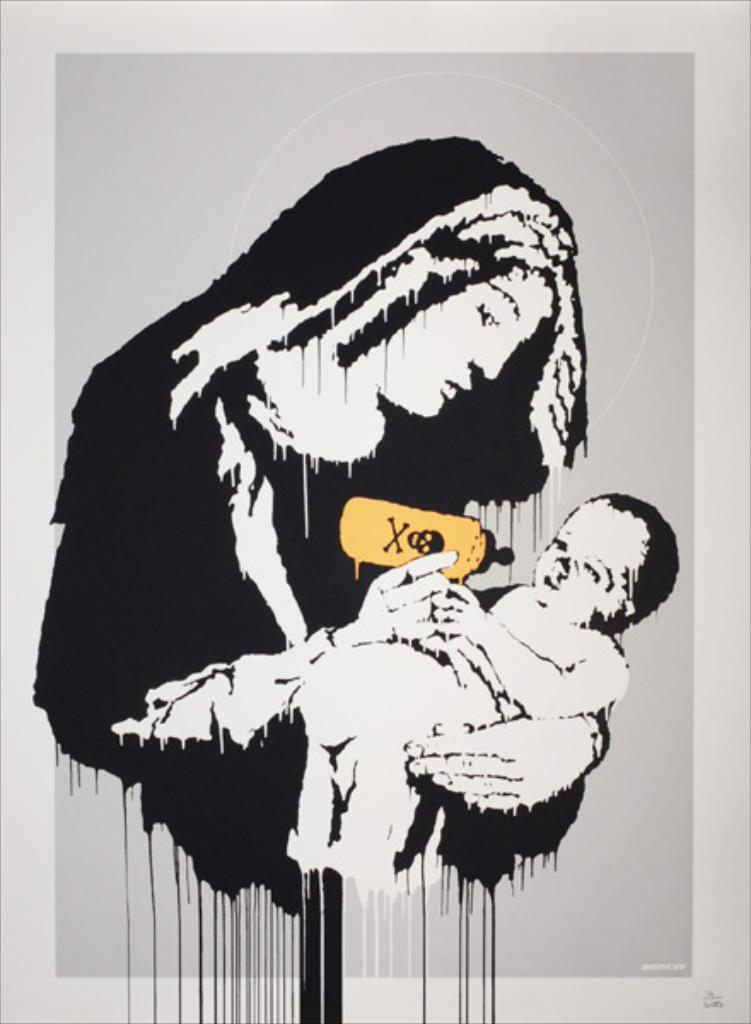What type of artwork is depicted in the image? The image is a painting. Who is the main subject in the painting? There is a lady in the painting. What is the lady doing in the painting? The lady is holding a baby. What is the lady holding in her hand? The lady is holding a feeding bottle in her hand. What is the lady's reaction to the flock of birds in the painting? There are no birds present in the painting, so the lady's reaction to a flock of birds cannot be determined. 